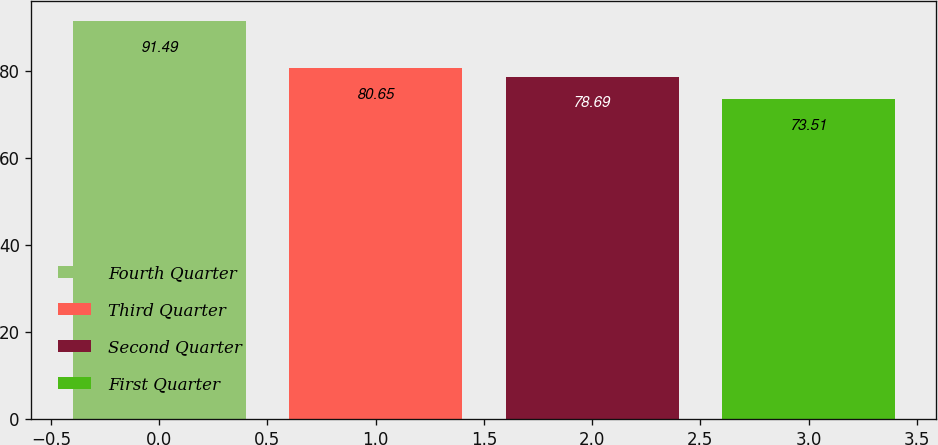<chart> <loc_0><loc_0><loc_500><loc_500><bar_chart><fcel>Fourth Quarter<fcel>Third Quarter<fcel>Second Quarter<fcel>First Quarter<nl><fcel>91.49<fcel>80.65<fcel>78.69<fcel>73.51<nl></chart> 